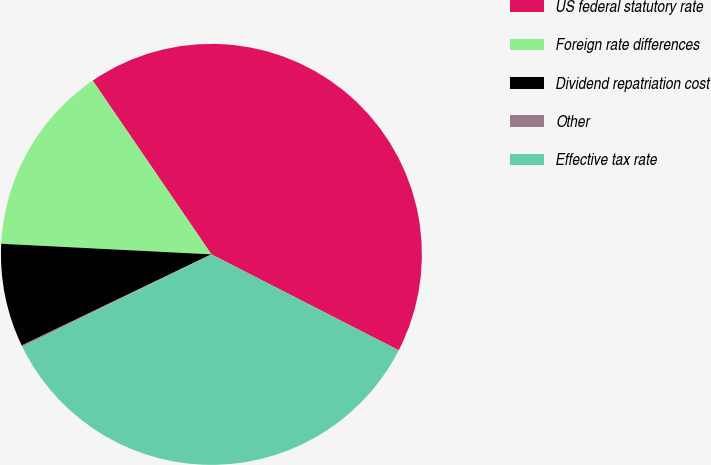Convert chart. <chart><loc_0><loc_0><loc_500><loc_500><pie_chart><fcel>US federal statutory rate<fcel>Foreign rate differences<fcel>Dividend repatriation cost<fcel>Other<fcel>Effective tax rate<nl><fcel>42.07%<fcel>14.66%<fcel>7.93%<fcel>0.12%<fcel>35.22%<nl></chart> 